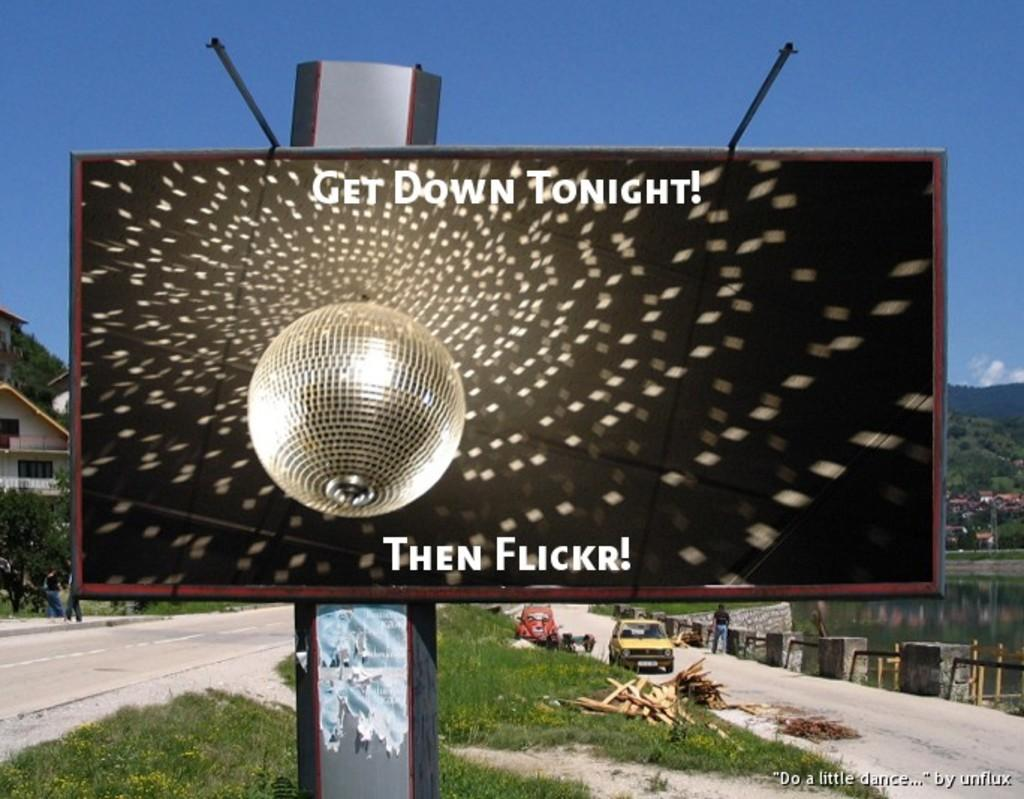<image>
Render a clear and concise summary of the photo. Get down tonight then flickr poster advertisement on a metal post. 